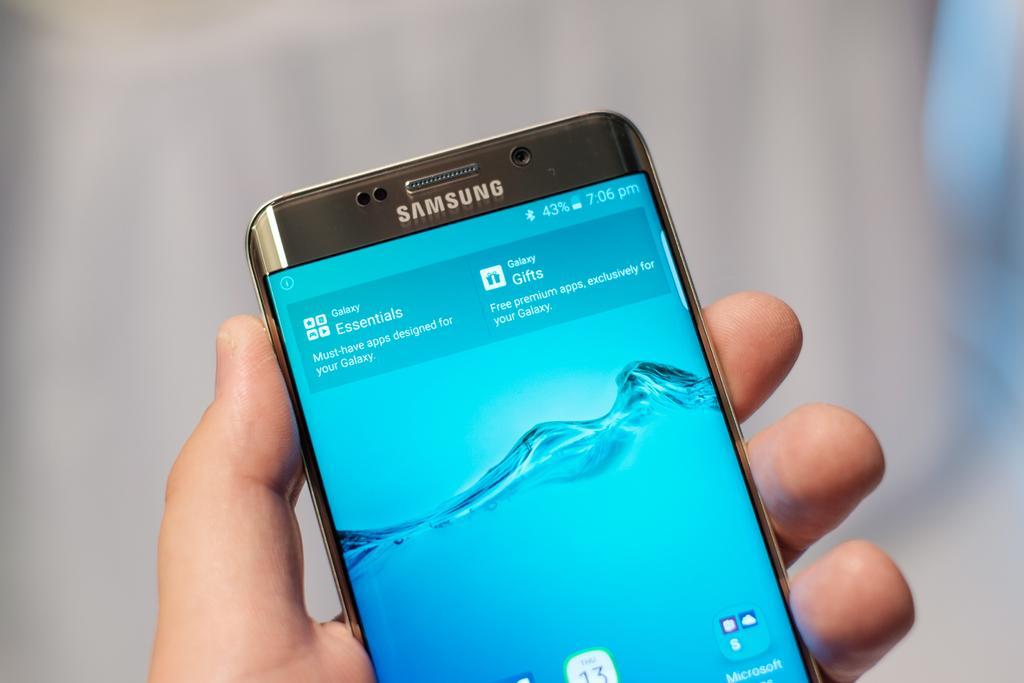Can you describe this image briefly? In this image we can see a person holding mobile phone in one of the hands. 